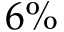Convert formula to latex. <formula><loc_0><loc_0><loc_500><loc_500>6 \%</formula> 